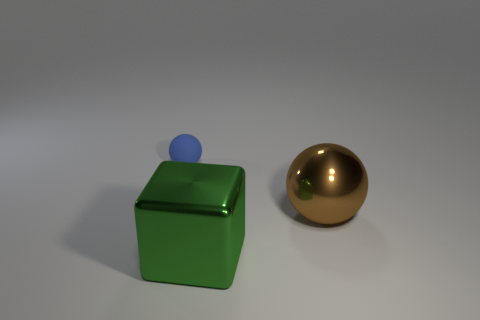Add 2 small yellow metal cylinders. How many objects exist? 5 Subtract all blocks. How many objects are left? 2 Subtract all blue metal cylinders. Subtract all balls. How many objects are left? 1 Add 2 large metal objects. How many large metal objects are left? 4 Add 2 tiny blue balls. How many tiny blue balls exist? 3 Subtract 0 gray balls. How many objects are left? 3 